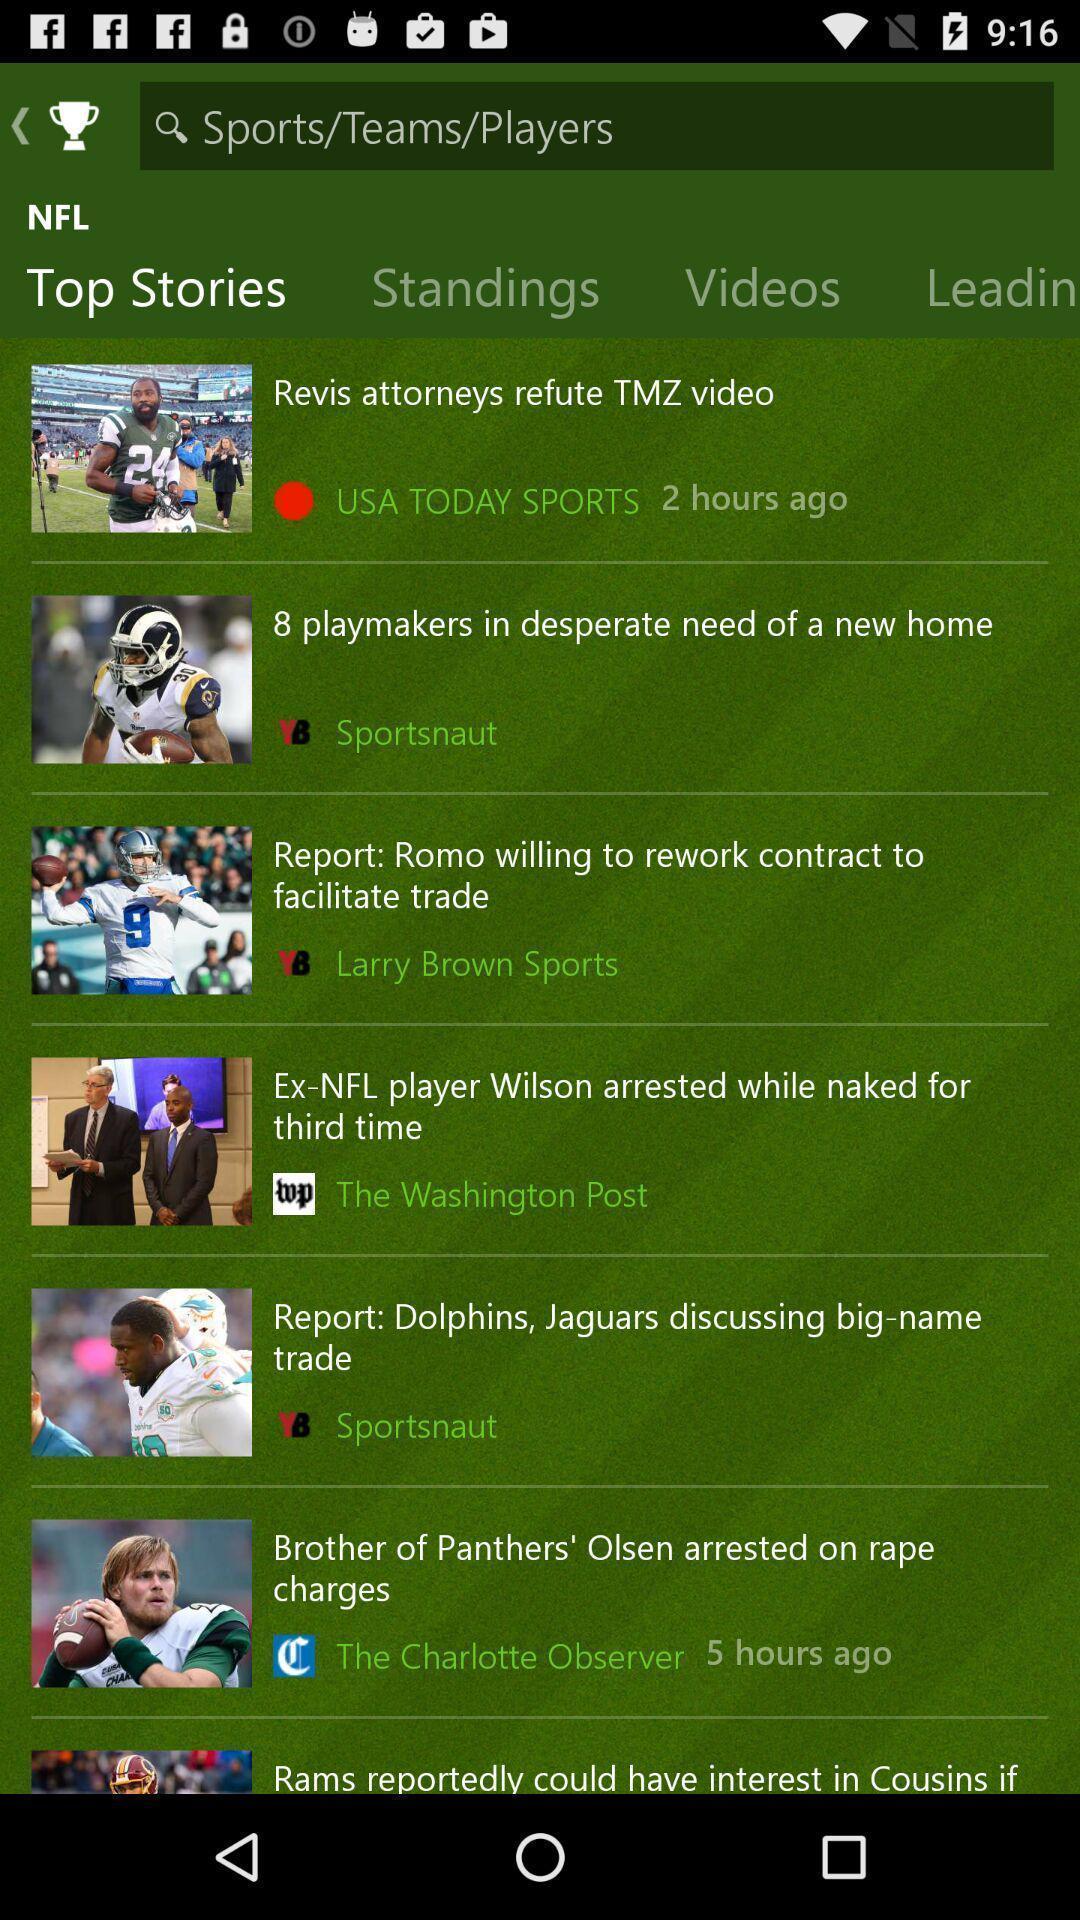Give me a summary of this screen capture. Screen showing top stories on teams/sports/players. 